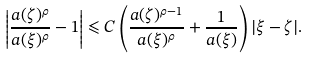<formula> <loc_0><loc_0><loc_500><loc_500>\left | \frac { a ( \zeta ) ^ { \rho } } { a ( \xi ) ^ { \rho } } - 1 \right | \leqslant C \left ( \frac { a ( \zeta ) ^ { \rho - 1 } } { a ( \xi ) ^ { \rho } } + \frac { 1 } { a ( \xi ) } \right ) | \xi - \zeta | .</formula> 